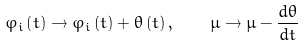<formula> <loc_0><loc_0><loc_500><loc_500>\varphi _ { i } \left ( t \right ) \rightarrow \varphi _ { i } \left ( t \right ) + \theta \left ( t \right ) , \quad \mu \rightarrow \mu - \frac { d \theta } { d t }</formula> 